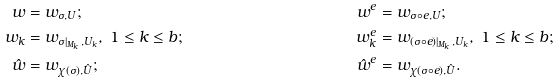<formula> <loc_0><loc_0><loc_500><loc_500>w & = w _ { \sigma , U } ; & w ^ { e } & = w _ { \sigma \circ e , U } ; \\ w _ { k } & = w _ { \sigma | _ { M _ { k } } , U _ { k } } , \ 1 \leq k \leq b ; & w _ { k } ^ { e } & = w _ { ( \sigma \circ e ) | _ { M _ { k } } , U _ { k } } , \ 1 \leq k \leq b ; \\ \hat { w } & = w _ { \chi ( \sigma ) , \hat { U } } ; & \hat { w } ^ { e } & = w _ { \chi ( \sigma \circ e ) , \hat { U } } .</formula> 